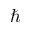Convert formula to latex. <formula><loc_0><loc_0><loc_500><loc_500>\hbar</formula> 